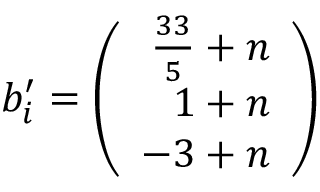<formula> <loc_0><loc_0><loc_500><loc_500>b _ { i } ^ { \prime } = \left ( \begin{array} { r } { { \frac { 3 3 } { 5 } + n } } \\ { 1 + n } \\ { - 3 + n } \end{array} \right )</formula> 